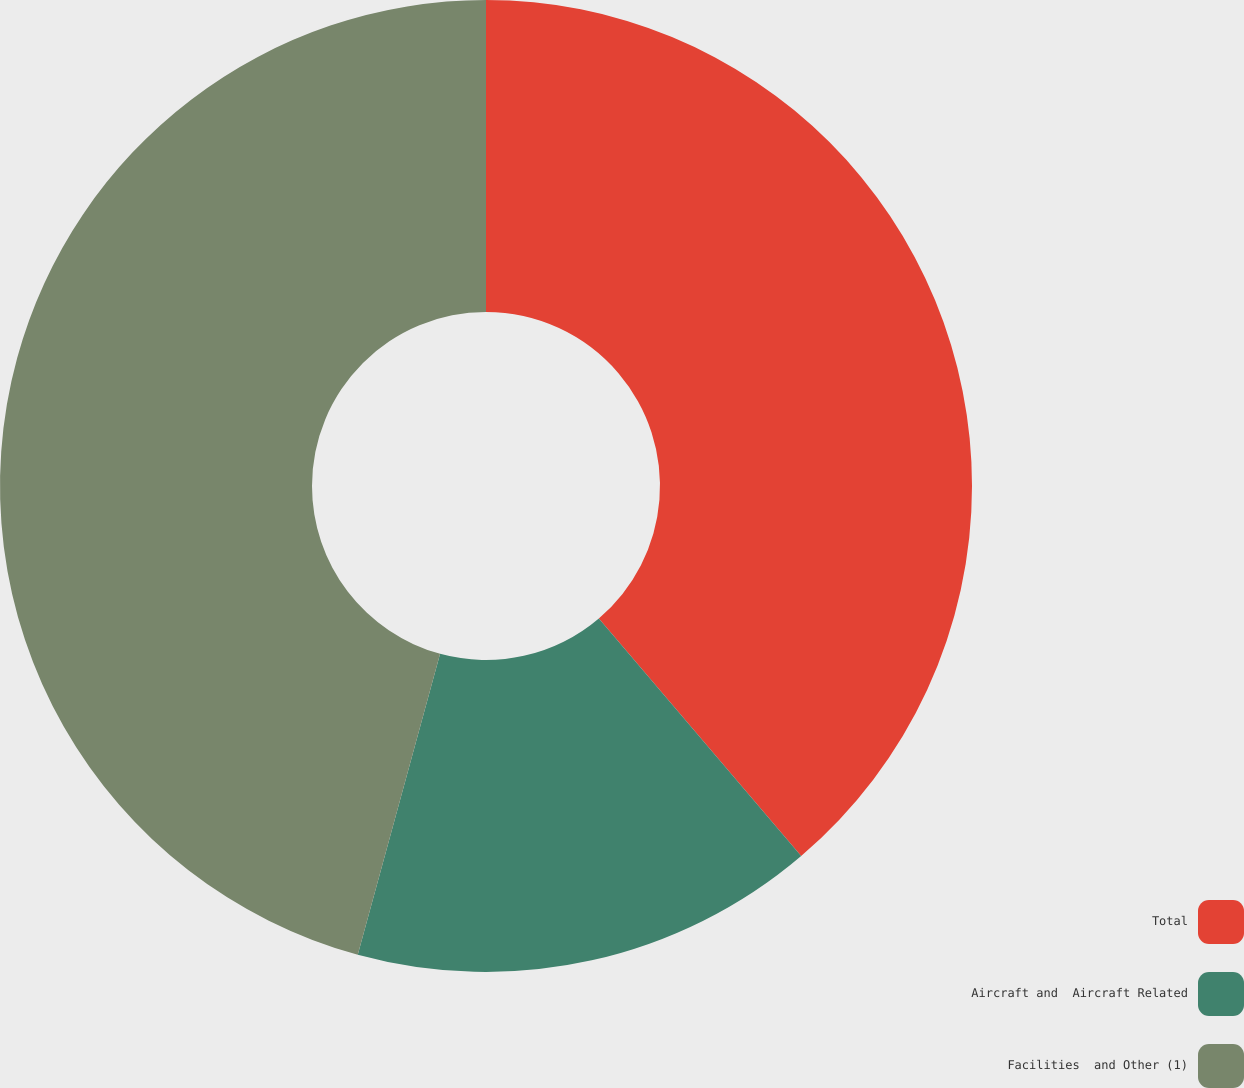Convert chart. <chart><loc_0><loc_0><loc_500><loc_500><pie_chart><fcel>Total<fcel>Aircraft and  Aircraft Related<fcel>Facilities  and Other (1)<nl><fcel>38.77%<fcel>15.48%<fcel>45.75%<nl></chart> 